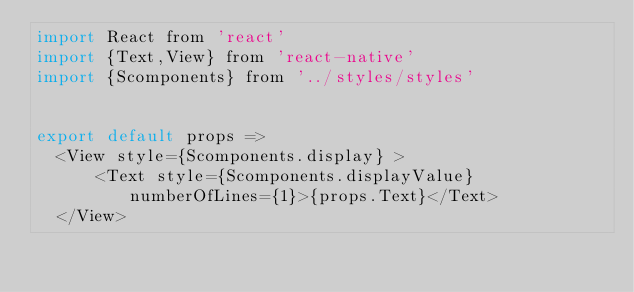Convert code to text. <code><loc_0><loc_0><loc_500><loc_500><_JavaScript_>import React from 'react'
import {Text,View} from 'react-native'
import {Scomponents} from '../styles/styles'


export default props => 
  <View style={Scomponents.display} >
      <Text style={Scomponents.displayValue} numberOfLines={1}>{props.Text}</Text>
  </View>
  
</code> 